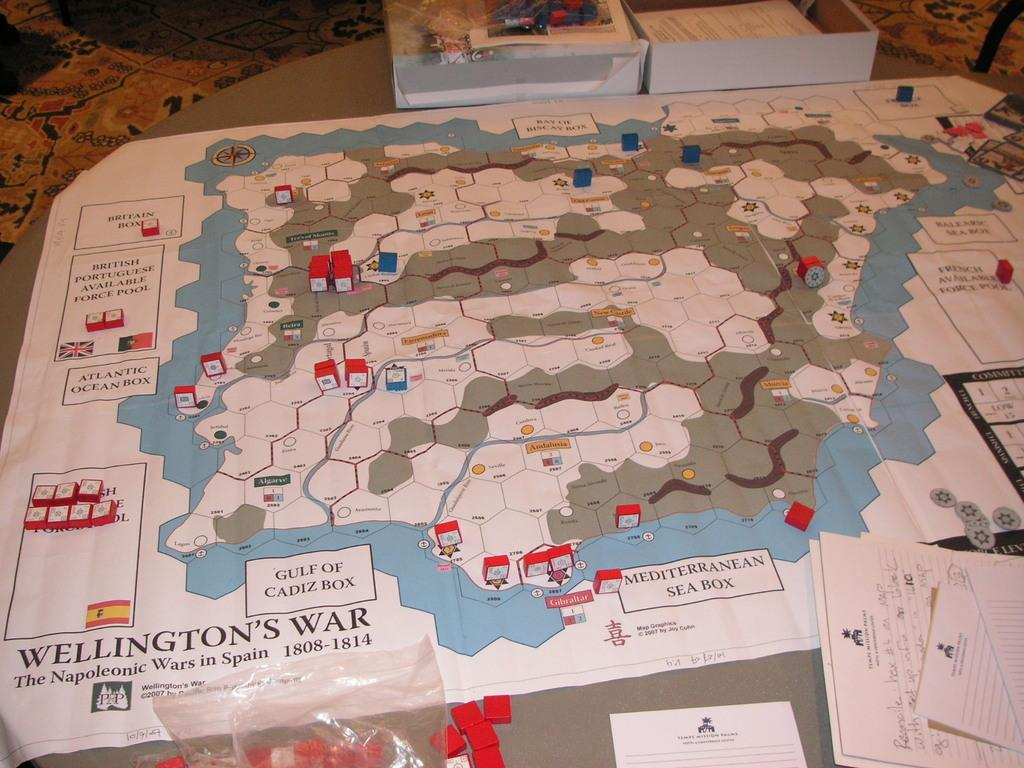<image>
Write a terse but informative summary of the picture. A strategy map of The Napoleonic Wars in Spain is adorned with red and white markers. 